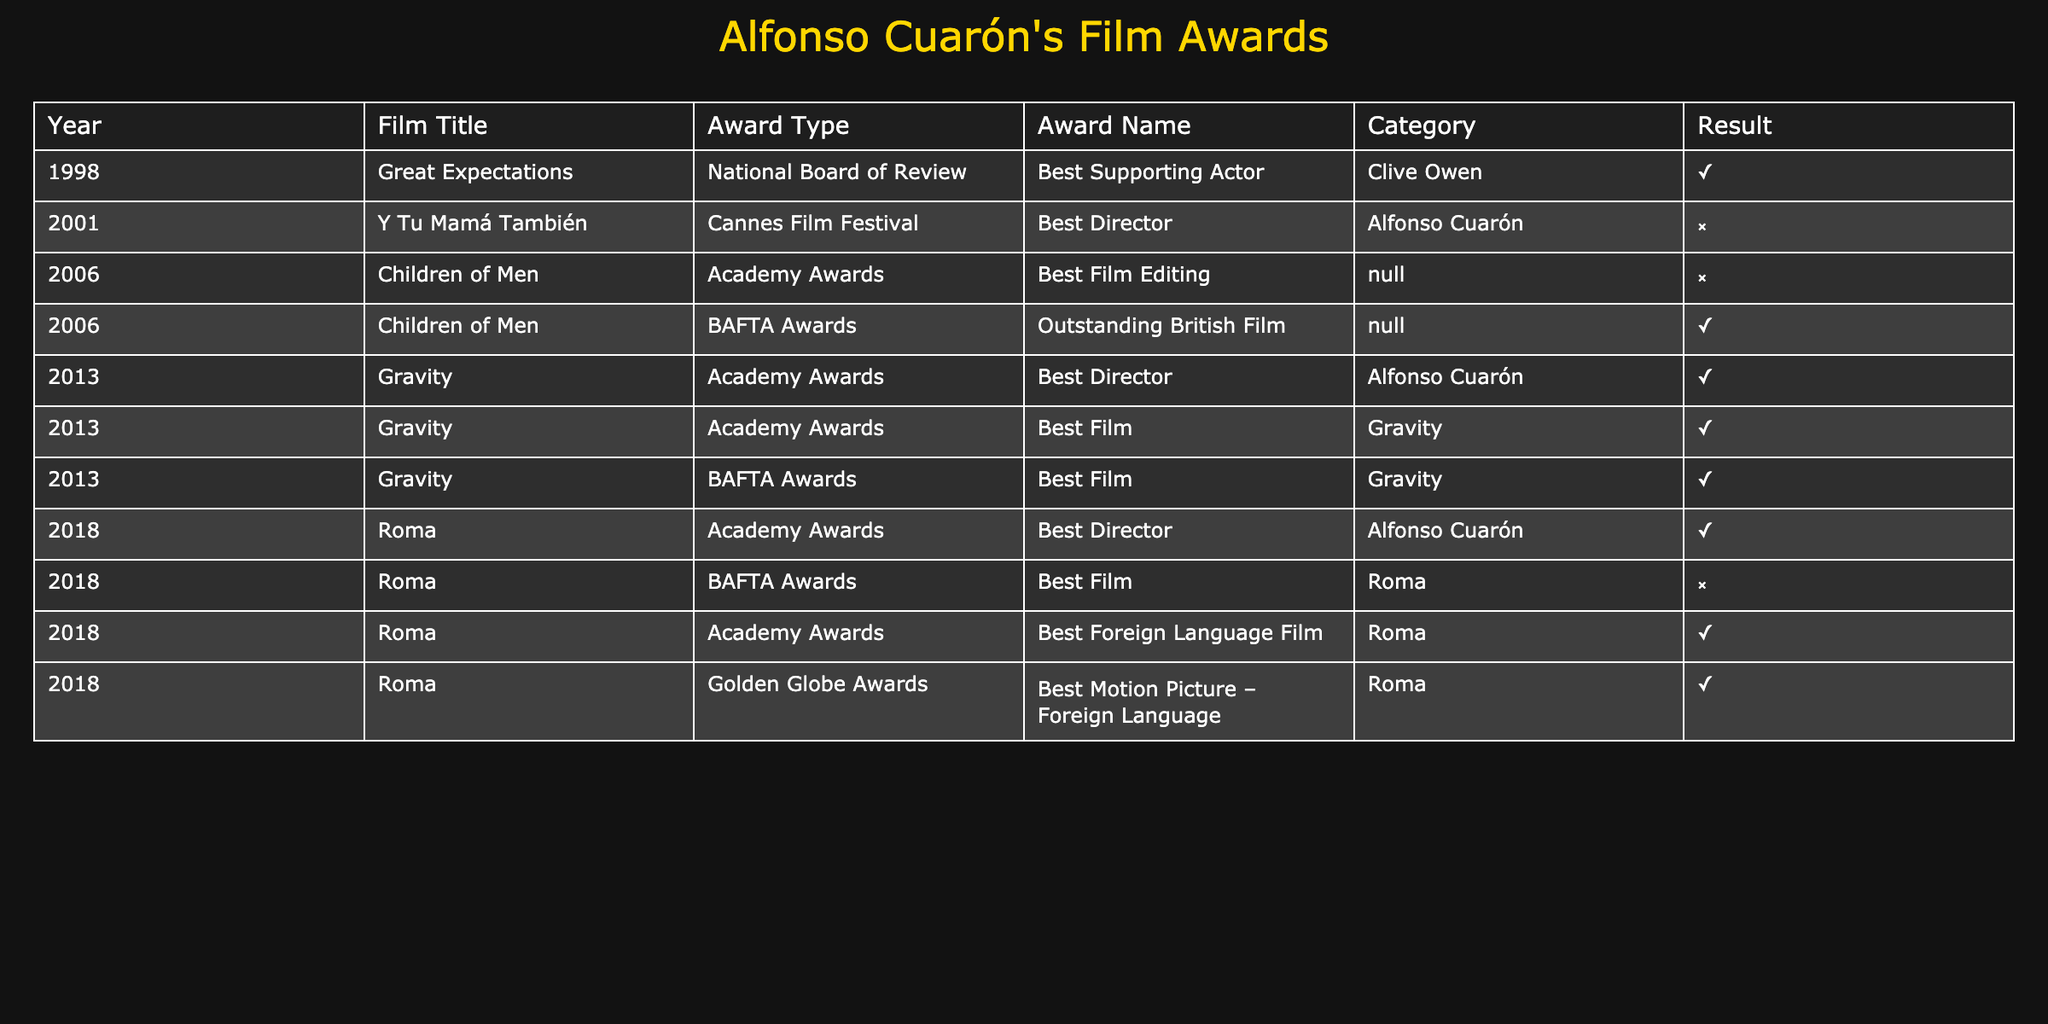What awards did "Gravity" win at the Academy Awards in 2013? The table shows that "Gravity" won two awards at the Academy Awards in 2013: Best Director, won by Alfonso Cuarón, and Best Film, also won for "Gravity".
Answer: Best Director and Best Film How many films directed by Alfonso Cuarón won awards? Looking at the table, "Children of Men", "Gravity", and "Roma" are the films directed by Alfonso Cuarón that won awards. "Children of Men" won one award, "Gravity" won three awards, and "Roma" won three awards. Therefore, there are seven wins across these films.
Answer: 7 Did "Y Tu Mamá También" win any awards in 2001? The table indicates that "Y Tu Mamá También" was nominated for an award at the Cannes Film Festival in 2001 but did not win any awards.
Answer: No Which film received the highest number of nominations without winning? The only film that received a nomination without winning is "Children of Men" for Best Film Editing in the Academy Awards, as all other releases listed won at least one award.
Answer: Children of Men What is the total number of awards won by "Roma"? From the table, "Roma" won three awards: Best Director, Best Foreign Language Film, and Best Motion Picture – Foreign Language. Each of these is listed as a win, making the total three.
Answer: 3 Which film won an award at the BAFTA Awards and what was it? The table shows that "Children of Men" won the Outstanding British Film award at the BAFTA Awards in 2006.
Answer: Children of Men, Outstanding British Film How many films directed by Alfonso Cuarón were nominated for an award without winning? Analyzing the table, "Y Tu Mamá También" and "Children of Men" were nominated without winning, making two films that fall into this category.
Answer: 2 Was "Roma" nominated for a BAFTA award? According to the table, "Roma" was nominated for the BAFTA Awards for Best Film but did not win.
Answer: Yes 